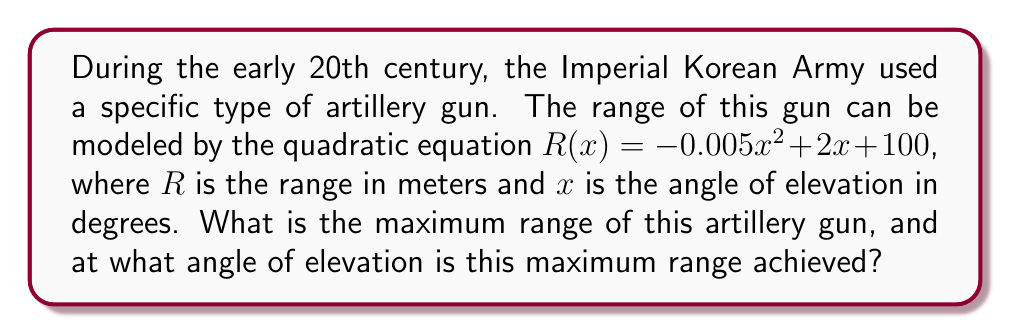Could you help me with this problem? To find the maximum range and the corresponding angle of elevation, we need to follow these steps:

1) The quadratic equation is in the form $R(x) = -0.005x^2 + 2x + 100$, which is a parabola that opens downward due to the negative coefficient of $x^2$.

2) For a quadratic equation in the form $f(x) = ax^2 + bx + c$, the x-coordinate of the vertex (which gives the angle of elevation for maximum range) is given by $x = -\frac{b}{2a}$.

3) Substituting our values:
   $a = -0.005$, $b = 2$
   $x = -\frac{2}{2(-0.005)} = -\frac{2}{-0.01} = 200$

4) The angle of elevation for maximum range is 200 degrees.

5) To find the maximum range, we substitute this x-value back into our original equation:

   $R(200) = -0.005(200)^2 + 2(200) + 100$
           $= -0.005(40000) + 400 + 100$
           $= -200 + 400 + 100$
           $= 300$

Therefore, the maximum range is 300 meters.
Answer: Maximum range: 300 meters; Angle of elevation: 200 degrees 